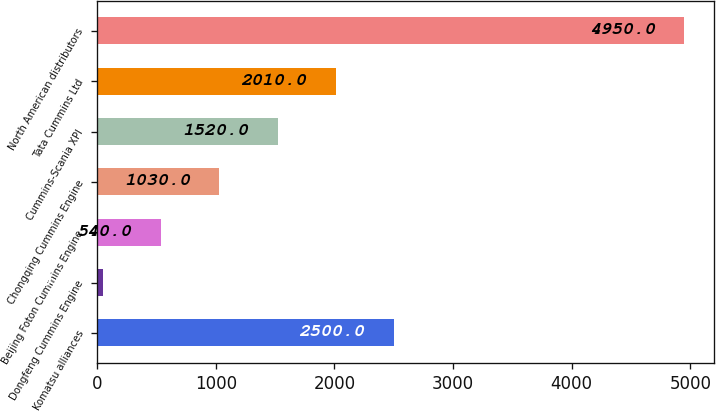<chart> <loc_0><loc_0><loc_500><loc_500><bar_chart><fcel>Komatsu alliances<fcel>Dongfeng Cummins Engine<fcel>Beijing Foton Cummins Engine<fcel>Chongqing Cummins Engine<fcel>Cummins-Scania XPI<fcel>Tata Cummins Ltd<fcel>North American distributors<nl><fcel>2500<fcel>50<fcel>540<fcel>1030<fcel>1520<fcel>2010<fcel>4950<nl></chart> 